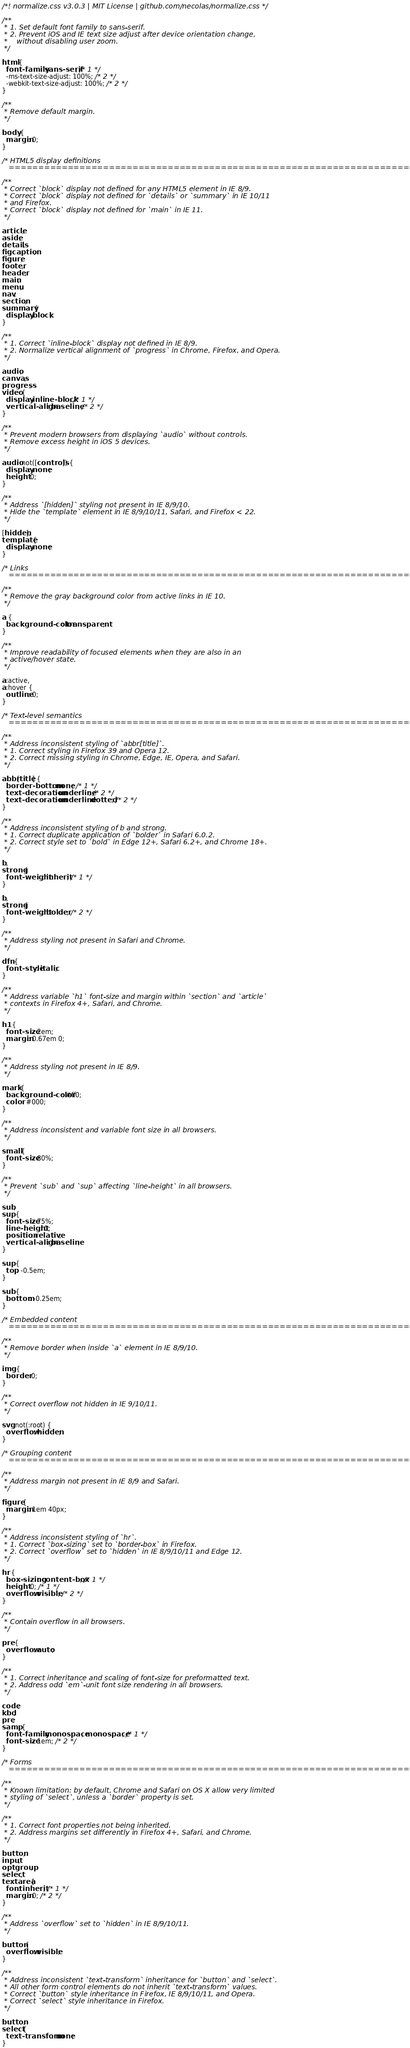Convert code to text. <code><loc_0><loc_0><loc_500><loc_500><_CSS_>/*! normalize.css v3.0.3 | MIT License | github.com/necolas/normalize.css */

/**
 * 1. Set default font family to sans-serif.
 * 2. Prevent iOS and IE text size adjust after device orientation change,
 *    without disabling user zoom.
 */

html {
  font-family: sans-serif; /* 1 */
  -ms-text-size-adjust: 100%; /* 2 */
  -webkit-text-size-adjust: 100%; /* 2 */
}

/**
 * Remove default margin.
 */

body {
  margin: 0;
}

/* HTML5 display definitions
   ========================================================================== */

/**
 * Correct `block` display not defined for any HTML5 element in IE 8/9.
 * Correct `block` display not defined for `details` or `summary` in IE 10/11
 * and Firefox.
 * Correct `block` display not defined for `main` in IE 11.
 */

article,
aside,
details,
figcaption,
figure,
footer,
header,
main,
menu,
nav,
section,
summary {
  display: block;
}

/**
 * 1. Correct `inline-block` display not defined in IE 8/9.
 * 2. Normalize vertical alignment of `progress` in Chrome, Firefox, and Opera.
 */

audio,
canvas,
progress,
video {
  display: inline-block; /* 1 */
  vertical-align: baseline; /* 2 */
}

/**
 * Prevent modern browsers from displaying `audio` without controls.
 * Remove excess height in iOS 5 devices.
 */

audio:not([controls]) {
  display: none;
  height: 0;
}

/**
 * Address `[hidden]` styling not present in IE 8/9/10.
 * Hide the `template` element in IE 8/9/10/11, Safari, and Firefox < 22.
 */

[hidden],
template {
  display: none;
}

/* Links
   ========================================================================== */

/**
 * Remove the gray background color from active links in IE 10.
 */

a {
  background-color: transparent;
}

/**
 * Improve readability of focused elements when they are also in an
 * active/hover state.
 */

a:active,
a:hover {
  outline: 0;
}

/* Text-level semantics
   ========================================================================== */

/**
 * Address inconsistent styling of `abbr[title]`.
 * 1. Correct styling in Firefox 39 and Opera 12.
 * 2. Correct missing styling in Chrome, Edge, IE, Opera, and Safari.
 */

abbr[title] {
  border-bottom: none; /* 1 */
  text-decoration: underline; /* 2 */
  text-decoration: underline dotted; /* 2 */
}

/**
 * Address inconsistent styling of b and strong.
 * 1. Correct duplicate application of `bolder` in Safari 6.0.2.
 * 2. Correct style set to `bold` in Edge 12+, Safari 6.2+, and Chrome 18+.
 */

b,
strong {
  font-weight: inherit; /* 1 */
}

b,
strong {
  font-weight: bolder; /* 2 */
}

/**
 * Address styling not present in Safari and Chrome.
 */

dfn {
  font-style: italic;
}

/**
 * Address variable `h1` font-size and margin within `section` and `article`
 * contexts in Firefox 4+, Safari, and Chrome.
 */

h1 {
  font-size: 2em;
  margin: 0.67em 0;
}

/**
 * Address styling not present in IE 8/9.
 */

mark {
  background-color: #ff0;
  color: #000;
}

/**
 * Address inconsistent and variable font size in all browsers.
 */

small {
  font-size: 80%;
}

/**
 * Prevent `sub` and `sup` affecting `line-height` in all browsers.
 */

sub,
sup {
  font-size: 75%;
  line-height: 0;
  position: relative;
  vertical-align: baseline;
}

sup {
  top: -0.5em;
}

sub {
  bottom: -0.25em;
}

/* Embedded content
   ========================================================================== */

/**
 * Remove border when inside `a` element in IE 8/9/10.
 */

img {
  border: 0;
}

/**
 * Correct overflow not hidden in IE 9/10/11.
 */

svg:not(:root) {
  overflow: hidden;
}

/* Grouping content
   ========================================================================== */

/**
 * Address margin not present in IE 8/9 and Safari.
 */

figure {
  margin: 1em 40px;
}

/**
 * Address inconsistent styling of `hr`.
 * 1. Correct `box-sizing` set to `border-box` in Firefox.
 * 2. Correct `overflow` set to `hidden` in IE 8/9/10/11 and Edge 12.
 */

hr {
  box-sizing: content-box; /* 1 */
  height: 0; /* 1 */
  overflow: visible; /* 2 */
}

/**
 * Contain overflow in all browsers.
 */

pre {
  overflow: auto;
}

/**
 * 1. Correct inheritance and scaling of font-size for preformatted text.
 * 2. Address odd `em`-unit font size rendering in all browsers.
 */

code,
kbd,
pre,
samp {
  font-family: monospace, monospace; /* 1 */
  font-size: 1em; /* 2 */
}

/* Forms
   ========================================================================== */

/**
 * Known limitation: by default, Chrome and Safari on OS X allow very limited
 * styling of `select`, unless a `border` property is set.
 */

/**
 * 1. Correct font properties not being inherited.
 * 2. Address margins set differently in Firefox 4+, Safari, and Chrome.
 */

button,
input,
optgroup,
select,
textarea {
  font: inherit; /* 1 */
  margin: 0; /* 2 */
}

/**
 * Address `overflow` set to `hidden` in IE 8/9/10/11.
 */

button {
  overflow: visible;
}

/**
 * Address inconsistent `text-transform` inheritance for `button` and `select`.
 * All other form control elements do not inherit `text-transform` values.
 * Correct `button` style inheritance in Firefox, IE 8/9/10/11, and Opera.
 * Correct `select` style inheritance in Firefox.
 */

button,
select {
  text-transform: none;
}
</code> 